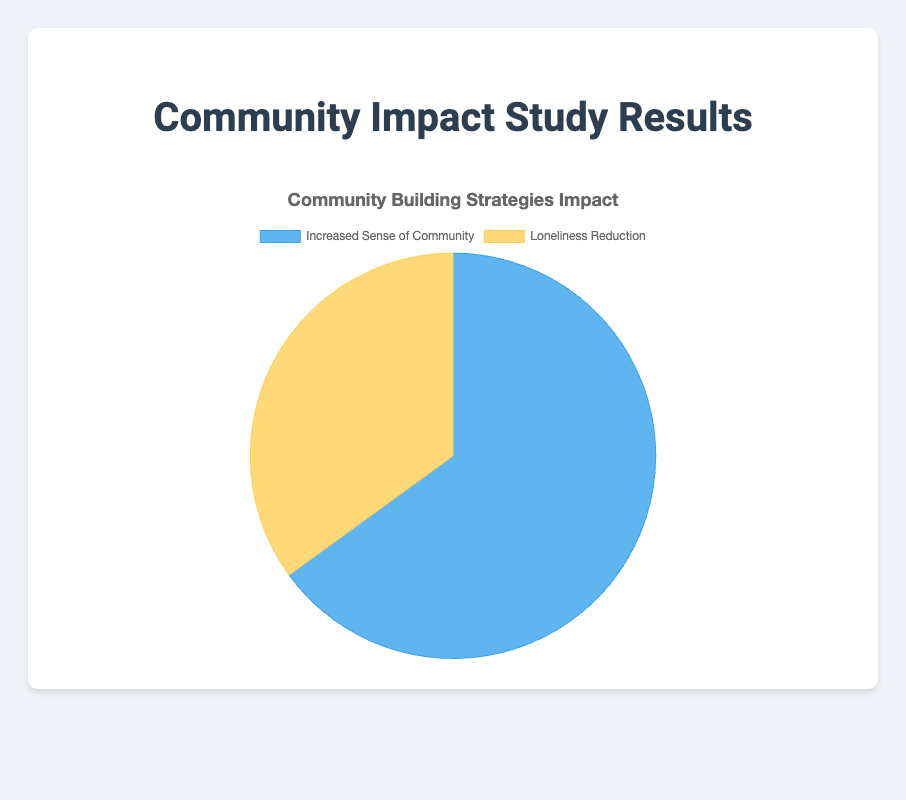What percent of the population reported an increased sense of community? The pie chart shows that 65% of the population reported an increased sense of community.
Answer: 65% What percent of the population experienced loneliness reduction? The pie chart indicates that 35% of the population experienced loneliness reduction.
Answer: 35% Which category has a higher percentage, increased sense of community or loneliness reduction? The pie chart shows that the increased sense of community has a higher percentage compared to loneliness reduction, with 65% versus 35%.
Answer: Increased sense of community What is the difference in percentage between those reporting an increased sense of community and those experiencing loneliness reduction? The difference is calculated by subtracting the percentage of loneliness reduction (35%) from the percentage of increased sense of community (65%). 65% - 35% = 30%.
Answer: 30% What percentage of the population did not report an increased sense of community? If 65% reported an increased sense of community, the remaining percentage that did not is 100% - 65%. 100% - 65% = 35%.
Answer: 35% If you were to extend this data to a population of 10,000 people, how many people would report an increased sense of community? To find out how many people report an increased sense of community in a population of 10,000, multiply the total population by the percentage. 10,000 * 0.65 = 6,500 people.
Answer: 6,500 people If you were to extend this data to a population of 10,000 people, how many people would experience loneliness reduction? To find out how many people experience loneliness reduction in a population of 10,000, multiply the total population by the percentage. 10,000 * 0.35 = 3,500 people.
Answer: 3,500 people Which visual attribute makes it clear that the 'Increased Sense of Community' category has a higher percentage than the 'Loneliness Reduction' category? The size of the pie slices visually indicates the difference, with the 'Increased Sense of Community' slice being larger than the 'Loneliness Reduction' slice.
Answer: The size of the pie slices Given that the sum of the percentages must be 100%, can you confirm if the given percentages (65% and 35%) sum up correctly? By adding the two percentages together, we get 65% + 35%. This equals 100%, confirming that the given data is correct.
Answer: 100% 